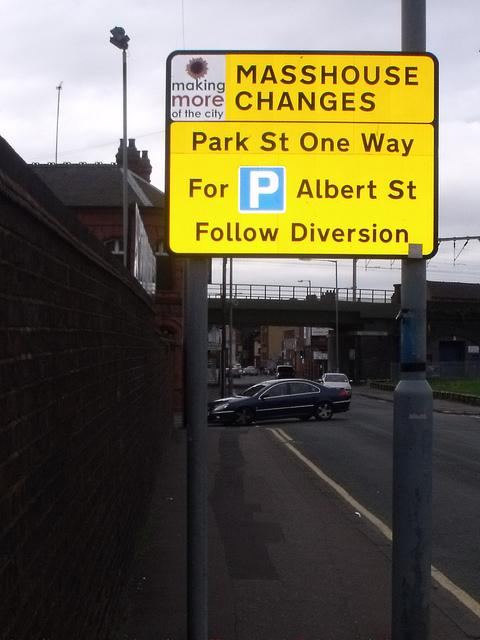Why is the yellow sign posted outdoors? Please explain your reasoning. to inform. The sign is for information. 